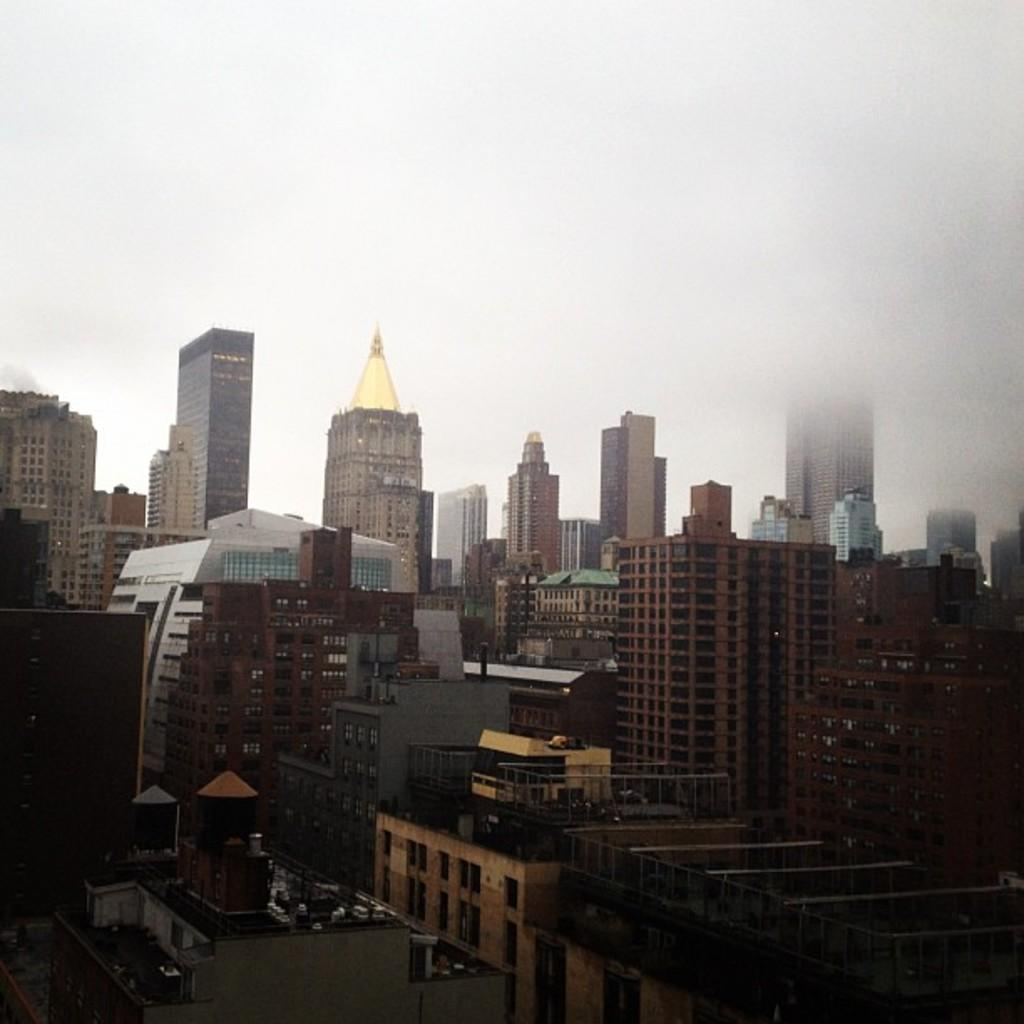What type of structures can be seen in the image? There are buildings and towers in the image. What is visible in the background of the image? The sky is visible in the background of the image. What type of blade is being used to cut the towers in the image? There is no blade or cutting action depicted in the image; it shows buildings and towers standing. 